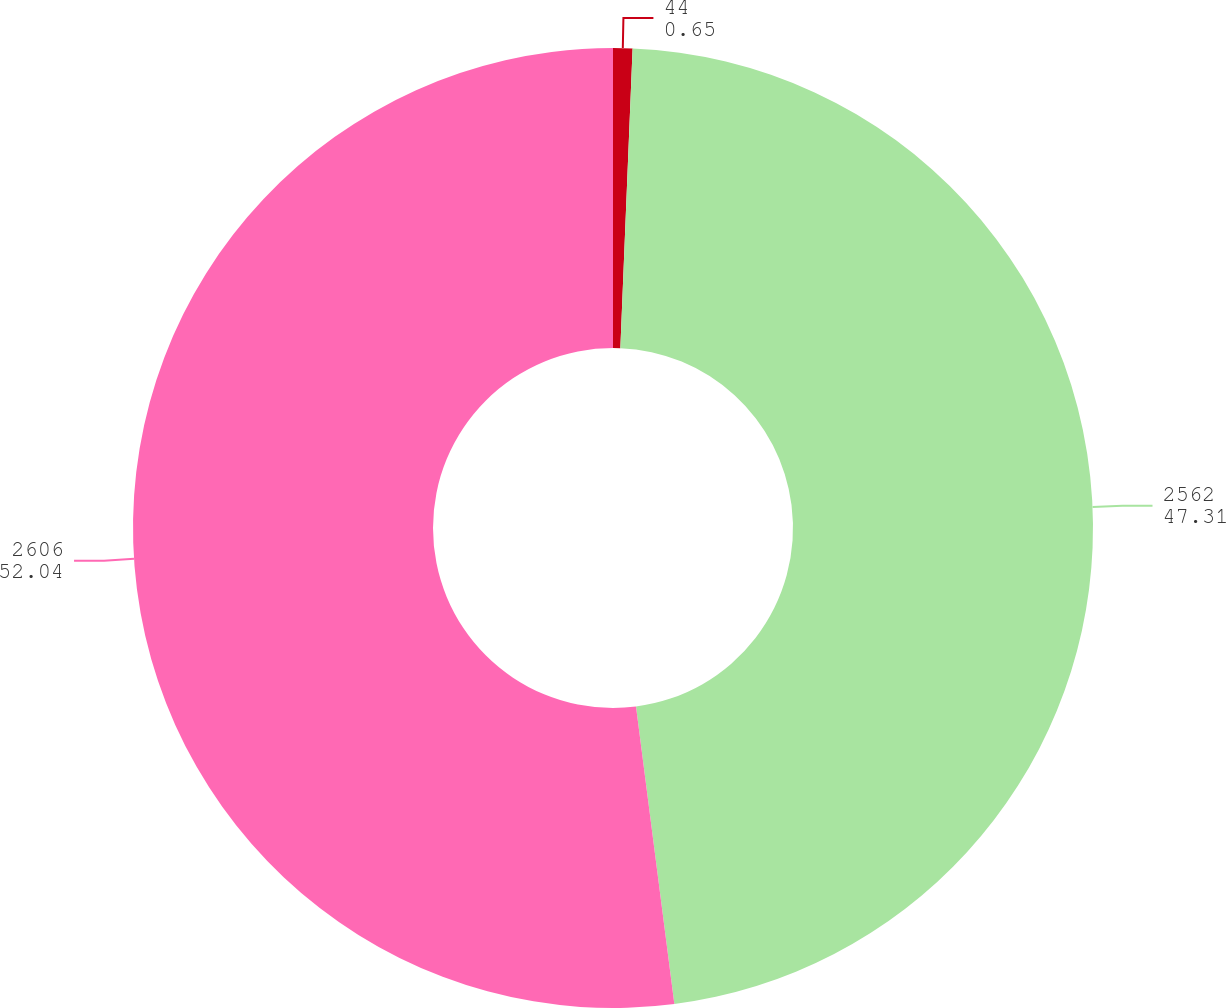Convert chart. <chart><loc_0><loc_0><loc_500><loc_500><pie_chart><fcel>44<fcel>2562<fcel>2606<nl><fcel>0.65%<fcel>47.31%<fcel>52.04%<nl></chart> 